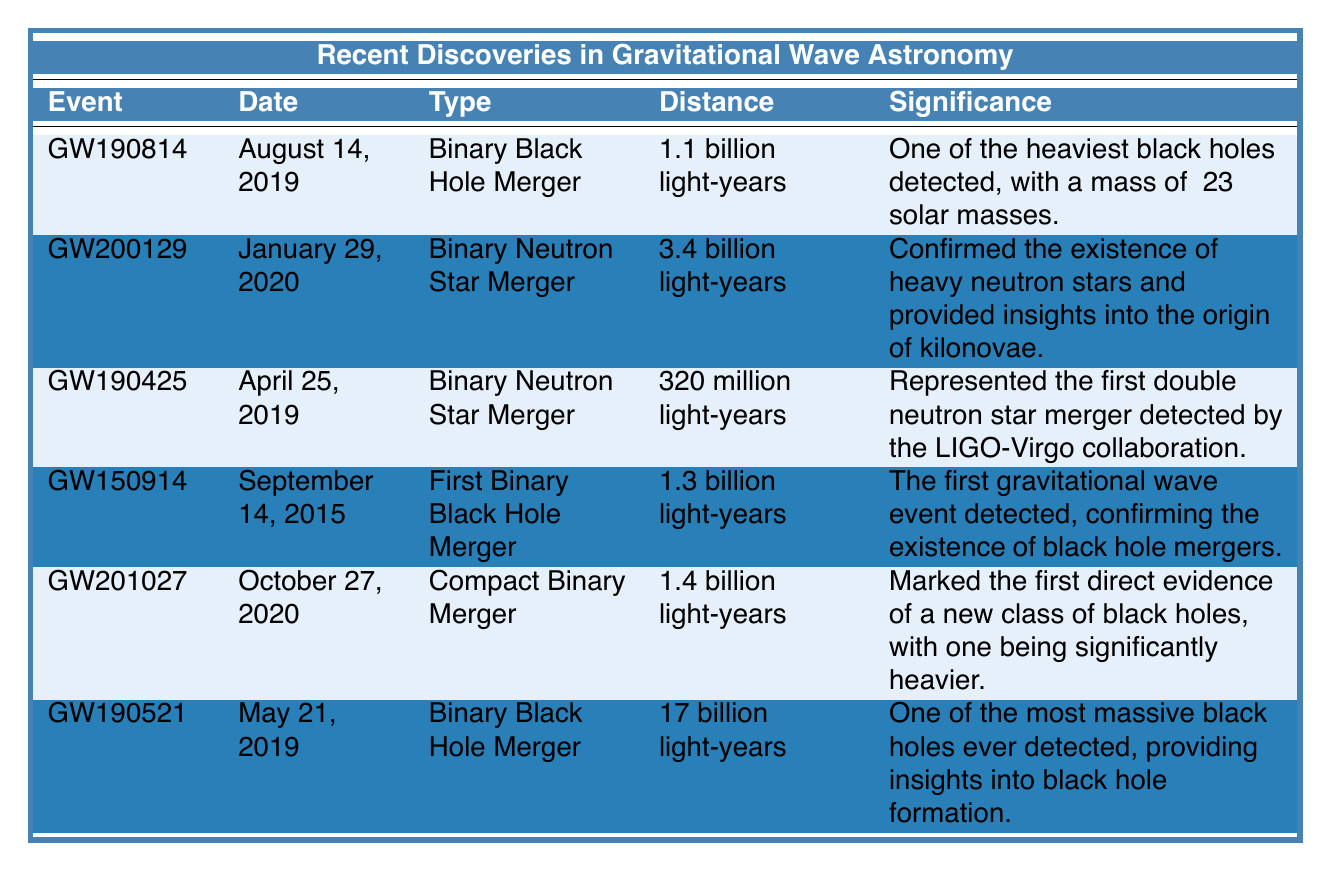What was the significance of the event GW150914? The table states that GW150914 was the first gravitational wave event detected, confirming the existence of black hole mergers.
Answer: It confirmed black hole mergers What is the distance of the GW190521 event? According to the table, GW190521 occurred at a distance of 17 billion light-years.
Answer: 17 billion light-years Which event marked the first double neutron star merger detected by the LIGO-Virgo collaboration? The table indicates that GW190425 represented the first double neutron star merger detected by the LIGO-Virgo collaboration.
Answer: GW190425 How many binary neutron star mergers are listed in the table? The table shows that there are two binary neutron star mergers: GW190425 and GW200129.
Answer: Two What is the average distance of the events GW190814 and GW200129? The distances are 1.1 billion light-years for GW190814 and 3.4 billion light-years for GW200129. The average is (1.1 + 3.4) / 2 = 2.25 billion light-years.
Answer: 2.25 billion light-years Did any of the events occur before 2019? According to the table, GW150914 and GW190425 occurred before 2019, on September 14, 2015, and April 25, 2019, respectively.
Answer: Yes Which event has the greatest significance regarding the understanding of black hole formation? The table highlights GW190521 as one of the most massive black holes ever detected, providing insights into black hole formation.
Answer: GW190521 What is the total distance of all the events listed in the table? The distances are: GW190814 (1.1 billion), GW200129 (3.4 billion), GW190425 (0.32 billion), GW150914 (1.3 billion), GW201027 (1.4 billion), and GW190521 (17 billion). Summing these gives: 1.1 + 3.4 + 0.32 + 1.3 + 1.4 + 17 = 24.52 billion light-years.
Answer: 24.52 billion light-years How many events are related to binary black hole mergers? The table specifies three events related to binary black hole mergers: GW190814, GW150914, and GW190521.
Answer: Three What was the type of event for GW200129? The table states that GW200129 is a Binary Neutron Star Merger.
Answer: Binary Neutron Star Merger 